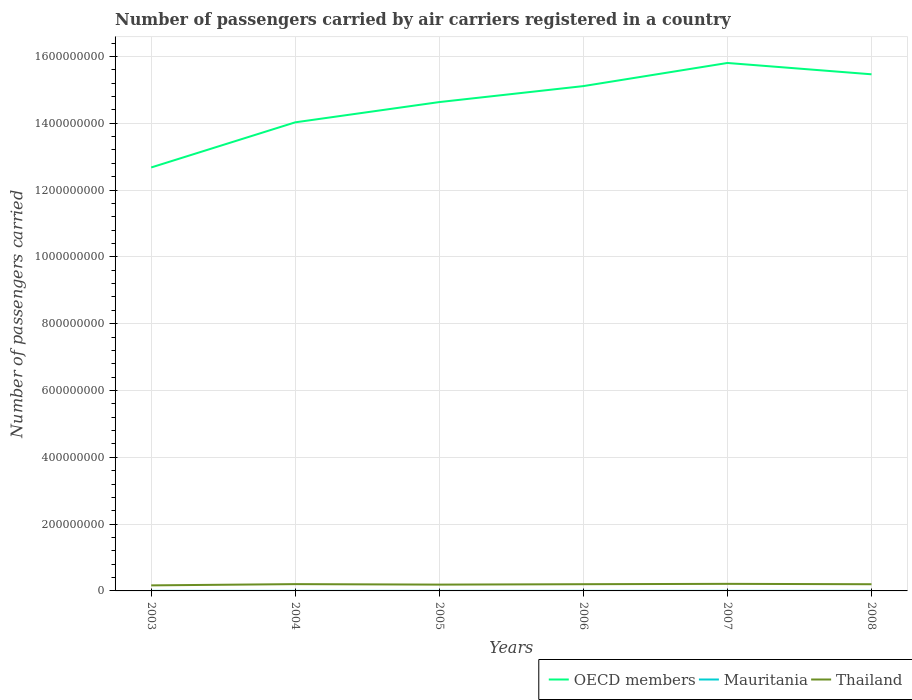Across all years, what is the maximum number of passengers carried by air carriers in OECD members?
Keep it short and to the point. 1.27e+09. In which year was the number of passengers carried by air carriers in OECD members maximum?
Give a very brief answer. 2003. What is the total number of passengers carried by air carriers in Thailand in the graph?
Your response must be concise. 1.20e+06. What is the difference between the highest and the second highest number of passengers carried by air carriers in Mauritania?
Your response must be concise. 3.85e+04. What is the difference between the highest and the lowest number of passengers carried by air carriers in Thailand?
Provide a succinct answer. 4. Are the values on the major ticks of Y-axis written in scientific E-notation?
Ensure brevity in your answer.  No. Does the graph contain any zero values?
Keep it short and to the point. No. Where does the legend appear in the graph?
Your answer should be compact. Bottom right. How many legend labels are there?
Your answer should be very brief. 3. How are the legend labels stacked?
Provide a short and direct response. Horizontal. What is the title of the graph?
Offer a terse response. Number of passengers carried by air carriers registered in a country. What is the label or title of the X-axis?
Offer a terse response. Years. What is the label or title of the Y-axis?
Make the answer very short. Number of passengers carried. What is the Number of passengers carried in OECD members in 2003?
Make the answer very short. 1.27e+09. What is the Number of passengers carried of Mauritania in 2003?
Offer a terse response. 1.16e+05. What is the Number of passengers carried in Thailand in 2003?
Provide a succinct answer. 1.66e+07. What is the Number of passengers carried in OECD members in 2004?
Keep it short and to the point. 1.40e+09. What is the Number of passengers carried in Mauritania in 2004?
Ensure brevity in your answer.  1.28e+05. What is the Number of passengers carried in Thailand in 2004?
Your response must be concise. 2.03e+07. What is the Number of passengers carried in OECD members in 2005?
Keep it short and to the point. 1.46e+09. What is the Number of passengers carried of Mauritania in 2005?
Offer a very short reply. 1.39e+05. What is the Number of passengers carried of Thailand in 2005?
Keep it short and to the point. 1.89e+07. What is the Number of passengers carried of OECD members in 2006?
Ensure brevity in your answer.  1.51e+09. What is the Number of passengers carried of Mauritania in 2006?
Ensure brevity in your answer.  1.49e+05. What is the Number of passengers carried in Thailand in 2006?
Keep it short and to the point. 2.01e+07. What is the Number of passengers carried of OECD members in 2007?
Your answer should be compact. 1.58e+09. What is the Number of passengers carried in Mauritania in 2007?
Your answer should be compact. 1.55e+05. What is the Number of passengers carried of Thailand in 2007?
Give a very brief answer. 2.12e+07. What is the Number of passengers carried of OECD members in 2008?
Make the answer very short. 1.55e+09. What is the Number of passengers carried of Mauritania in 2008?
Give a very brief answer. 1.54e+05. What is the Number of passengers carried of Thailand in 2008?
Your response must be concise. 2.00e+07. Across all years, what is the maximum Number of passengers carried in OECD members?
Give a very brief answer. 1.58e+09. Across all years, what is the maximum Number of passengers carried of Mauritania?
Keep it short and to the point. 1.55e+05. Across all years, what is the maximum Number of passengers carried in Thailand?
Keep it short and to the point. 2.12e+07. Across all years, what is the minimum Number of passengers carried in OECD members?
Keep it short and to the point. 1.27e+09. Across all years, what is the minimum Number of passengers carried in Mauritania?
Make the answer very short. 1.16e+05. Across all years, what is the minimum Number of passengers carried of Thailand?
Make the answer very short. 1.66e+07. What is the total Number of passengers carried of OECD members in the graph?
Your answer should be very brief. 8.77e+09. What is the total Number of passengers carried in Mauritania in the graph?
Keep it short and to the point. 8.41e+05. What is the total Number of passengers carried of Thailand in the graph?
Offer a terse response. 1.17e+08. What is the difference between the Number of passengers carried of OECD members in 2003 and that in 2004?
Make the answer very short. -1.35e+08. What is the difference between the Number of passengers carried of Mauritania in 2003 and that in 2004?
Offer a terse response. -1.22e+04. What is the difference between the Number of passengers carried of Thailand in 2003 and that in 2004?
Provide a succinct answer. -3.72e+06. What is the difference between the Number of passengers carried in OECD members in 2003 and that in 2005?
Keep it short and to the point. -1.96e+08. What is the difference between the Number of passengers carried in Mauritania in 2003 and that in 2005?
Make the answer very short. -2.25e+04. What is the difference between the Number of passengers carried of Thailand in 2003 and that in 2005?
Give a very brief answer. -2.28e+06. What is the difference between the Number of passengers carried in OECD members in 2003 and that in 2006?
Make the answer very short. -2.44e+08. What is the difference between the Number of passengers carried of Mauritania in 2003 and that in 2006?
Keep it short and to the point. -3.31e+04. What is the difference between the Number of passengers carried in Thailand in 2003 and that in 2006?
Give a very brief answer. -3.48e+06. What is the difference between the Number of passengers carried of OECD members in 2003 and that in 2007?
Give a very brief answer. -3.13e+08. What is the difference between the Number of passengers carried in Mauritania in 2003 and that in 2007?
Provide a short and direct response. -3.85e+04. What is the difference between the Number of passengers carried in Thailand in 2003 and that in 2007?
Offer a terse response. -4.57e+06. What is the difference between the Number of passengers carried in OECD members in 2003 and that in 2008?
Your response must be concise. -2.79e+08. What is the difference between the Number of passengers carried of Mauritania in 2003 and that in 2008?
Give a very brief answer. -3.78e+04. What is the difference between the Number of passengers carried of Thailand in 2003 and that in 2008?
Your answer should be compact. -3.37e+06. What is the difference between the Number of passengers carried in OECD members in 2004 and that in 2005?
Your answer should be compact. -6.06e+07. What is the difference between the Number of passengers carried in Mauritania in 2004 and that in 2005?
Make the answer very short. -1.03e+04. What is the difference between the Number of passengers carried in Thailand in 2004 and that in 2005?
Offer a very short reply. 1.44e+06. What is the difference between the Number of passengers carried in OECD members in 2004 and that in 2006?
Provide a succinct answer. -1.08e+08. What is the difference between the Number of passengers carried of Mauritania in 2004 and that in 2006?
Give a very brief answer. -2.09e+04. What is the difference between the Number of passengers carried in Thailand in 2004 and that in 2006?
Provide a succinct answer. 2.40e+05. What is the difference between the Number of passengers carried in OECD members in 2004 and that in 2007?
Offer a very short reply. -1.78e+08. What is the difference between the Number of passengers carried in Mauritania in 2004 and that in 2007?
Offer a very short reply. -2.63e+04. What is the difference between the Number of passengers carried of Thailand in 2004 and that in 2007?
Your answer should be compact. -8.49e+05. What is the difference between the Number of passengers carried in OECD members in 2004 and that in 2008?
Your answer should be compact. -1.44e+08. What is the difference between the Number of passengers carried in Mauritania in 2004 and that in 2008?
Your answer should be very brief. -2.56e+04. What is the difference between the Number of passengers carried of Thailand in 2004 and that in 2008?
Make the answer very short. 3.49e+05. What is the difference between the Number of passengers carried in OECD members in 2005 and that in 2006?
Give a very brief answer. -4.78e+07. What is the difference between the Number of passengers carried of Mauritania in 2005 and that in 2006?
Keep it short and to the point. -1.06e+04. What is the difference between the Number of passengers carried in Thailand in 2005 and that in 2006?
Provide a short and direct response. -1.20e+06. What is the difference between the Number of passengers carried in OECD members in 2005 and that in 2007?
Ensure brevity in your answer.  -1.17e+08. What is the difference between the Number of passengers carried in Mauritania in 2005 and that in 2007?
Offer a very short reply. -1.61e+04. What is the difference between the Number of passengers carried of Thailand in 2005 and that in 2007?
Your answer should be very brief. -2.29e+06. What is the difference between the Number of passengers carried of OECD members in 2005 and that in 2008?
Your response must be concise. -8.31e+07. What is the difference between the Number of passengers carried in Mauritania in 2005 and that in 2008?
Ensure brevity in your answer.  -1.53e+04. What is the difference between the Number of passengers carried in Thailand in 2005 and that in 2008?
Provide a short and direct response. -1.09e+06. What is the difference between the Number of passengers carried in OECD members in 2006 and that in 2007?
Provide a short and direct response. -6.92e+07. What is the difference between the Number of passengers carried in Mauritania in 2006 and that in 2007?
Make the answer very short. -5474. What is the difference between the Number of passengers carried of Thailand in 2006 and that in 2007?
Make the answer very short. -1.09e+06. What is the difference between the Number of passengers carried of OECD members in 2006 and that in 2008?
Give a very brief answer. -3.53e+07. What is the difference between the Number of passengers carried of Mauritania in 2006 and that in 2008?
Your answer should be compact. -4707. What is the difference between the Number of passengers carried in Thailand in 2006 and that in 2008?
Your response must be concise. 1.09e+05. What is the difference between the Number of passengers carried of OECD members in 2007 and that in 2008?
Your answer should be very brief. 3.39e+07. What is the difference between the Number of passengers carried of Mauritania in 2007 and that in 2008?
Give a very brief answer. 767. What is the difference between the Number of passengers carried in Thailand in 2007 and that in 2008?
Your answer should be compact. 1.20e+06. What is the difference between the Number of passengers carried of OECD members in 2003 and the Number of passengers carried of Mauritania in 2004?
Offer a very short reply. 1.27e+09. What is the difference between the Number of passengers carried of OECD members in 2003 and the Number of passengers carried of Thailand in 2004?
Your answer should be very brief. 1.25e+09. What is the difference between the Number of passengers carried in Mauritania in 2003 and the Number of passengers carried in Thailand in 2004?
Make the answer very short. -2.02e+07. What is the difference between the Number of passengers carried in OECD members in 2003 and the Number of passengers carried in Mauritania in 2005?
Make the answer very short. 1.27e+09. What is the difference between the Number of passengers carried in OECD members in 2003 and the Number of passengers carried in Thailand in 2005?
Keep it short and to the point. 1.25e+09. What is the difference between the Number of passengers carried in Mauritania in 2003 and the Number of passengers carried in Thailand in 2005?
Your answer should be very brief. -1.88e+07. What is the difference between the Number of passengers carried in OECD members in 2003 and the Number of passengers carried in Mauritania in 2006?
Make the answer very short. 1.27e+09. What is the difference between the Number of passengers carried in OECD members in 2003 and the Number of passengers carried in Thailand in 2006?
Provide a short and direct response. 1.25e+09. What is the difference between the Number of passengers carried in Mauritania in 2003 and the Number of passengers carried in Thailand in 2006?
Offer a very short reply. -2.00e+07. What is the difference between the Number of passengers carried in OECD members in 2003 and the Number of passengers carried in Mauritania in 2007?
Offer a terse response. 1.27e+09. What is the difference between the Number of passengers carried of OECD members in 2003 and the Number of passengers carried of Thailand in 2007?
Your response must be concise. 1.25e+09. What is the difference between the Number of passengers carried in Mauritania in 2003 and the Number of passengers carried in Thailand in 2007?
Your answer should be very brief. -2.11e+07. What is the difference between the Number of passengers carried of OECD members in 2003 and the Number of passengers carried of Mauritania in 2008?
Give a very brief answer. 1.27e+09. What is the difference between the Number of passengers carried in OECD members in 2003 and the Number of passengers carried in Thailand in 2008?
Offer a terse response. 1.25e+09. What is the difference between the Number of passengers carried of Mauritania in 2003 and the Number of passengers carried of Thailand in 2008?
Provide a succinct answer. -1.99e+07. What is the difference between the Number of passengers carried of OECD members in 2004 and the Number of passengers carried of Mauritania in 2005?
Provide a succinct answer. 1.40e+09. What is the difference between the Number of passengers carried of OECD members in 2004 and the Number of passengers carried of Thailand in 2005?
Provide a short and direct response. 1.38e+09. What is the difference between the Number of passengers carried in Mauritania in 2004 and the Number of passengers carried in Thailand in 2005?
Offer a terse response. -1.88e+07. What is the difference between the Number of passengers carried of OECD members in 2004 and the Number of passengers carried of Mauritania in 2006?
Offer a terse response. 1.40e+09. What is the difference between the Number of passengers carried in OECD members in 2004 and the Number of passengers carried in Thailand in 2006?
Provide a short and direct response. 1.38e+09. What is the difference between the Number of passengers carried of Mauritania in 2004 and the Number of passengers carried of Thailand in 2006?
Your answer should be very brief. -2.00e+07. What is the difference between the Number of passengers carried of OECD members in 2004 and the Number of passengers carried of Mauritania in 2007?
Your answer should be compact. 1.40e+09. What is the difference between the Number of passengers carried in OECD members in 2004 and the Number of passengers carried in Thailand in 2007?
Keep it short and to the point. 1.38e+09. What is the difference between the Number of passengers carried in Mauritania in 2004 and the Number of passengers carried in Thailand in 2007?
Your answer should be very brief. -2.11e+07. What is the difference between the Number of passengers carried of OECD members in 2004 and the Number of passengers carried of Mauritania in 2008?
Your answer should be very brief. 1.40e+09. What is the difference between the Number of passengers carried in OECD members in 2004 and the Number of passengers carried in Thailand in 2008?
Provide a succinct answer. 1.38e+09. What is the difference between the Number of passengers carried in Mauritania in 2004 and the Number of passengers carried in Thailand in 2008?
Your response must be concise. -1.99e+07. What is the difference between the Number of passengers carried in OECD members in 2005 and the Number of passengers carried in Mauritania in 2006?
Give a very brief answer. 1.46e+09. What is the difference between the Number of passengers carried in OECD members in 2005 and the Number of passengers carried in Thailand in 2006?
Your response must be concise. 1.44e+09. What is the difference between the Number of passengers carried of Mauritania in 2005 and the Number of passengers carried of Thailand in 2006?
Your response must be concise. -2.00e+07. What is the difference between the Number of passengers carried of OECD members in 2005 and the Number of passengers carried of Mauritania in 2007?
Your answer should be compact. 1.46e+09. What is the difference between the Number of passengers carried in OECD members in 2005 and the Number of passengers carried in Thailand in 2007?
Your answer should be very brief. 1.44e+09. What is the difference between the Number of passengers carried in Mauritania in 2005 and the Number of passengers carried in Thailand in 2007?
Your response must be concise. -2.11e+07. What is the difference between the Number of passengers carried of OECD members in 2005 and the Number of passengers carried of Mauritania in 2008?
Give a very brief answer. 1.46e+09. What is the difference between the Number of passengers carried in OECD members in 2005 and the Number of passengers carried in Thailand in 2008?
Your response must be concise. 1.44e+09. What is the difference between the Number of passengers carried in Mauritania in 2005 and the Number of passengers carried in Thailand in 2008?
Provide a short and direct response. -1.99e+07. What is the difference between the Number of passengers carried of OECD members in 2006 and the Number of passengers carried of Mauritania in 2007?
Your answer should be very brief. 1.51e+09. What is the difference between the Number of passengers carried of OECD members in 2006 and the Number of passengers carried of Thailand in 2007?
Provide a succinct answer. 1.49e+09. What is the difference between the Number of passengers carried of Mauritania in 2006 and the Number of passengers carried of Thailand in 2007?
Make the answer very short. -2.10e+07. What is the difference between the Number of passengers carried in OECD members in 2006 and the Number of passengers carried in Mauritania in 2008?
Make the answer very short. 1.51e+09. What is the difference between the Number of passengers carried of OECD members in 2006 and the Number of passengers carried of Thailand in 2008?
Ensure brevity in your answer.  1.49e+09. What is the difference between the Number of passengers carried in Mauritania in 2006 and the Number of passengers carried in Thailand in 2008?
Provide a succinct answer. -1.98e+07. What is the difference between the Number of passengers carried in OECD members in 2007 and the Number of passengers carried in Mauritania in 2008?
Give a very brief answer. 1.58e+09. What is the difference between the Number of passengers carried in OECD members in 2007 and the Number of passengers carried in Thailand in 2008?
Your answer should be very brief. 1.56e+09. What is the difference between the Number of passengers carried of Mauritania in 2007 and the Number of passengers carried of Thailand in 2008?
Ensure brevity in your answer.  -1.98e+07. What is the average Number of passengers carried of OECD members per year?
Ensure brevity in your answer.  1.46e+09. What is the average Number of passengers carried of Mauritania per year?
Your answer should be compact. 1.40e+05. What is the average Number of passengers carried of Thailand per year?
Keep it short and to the point. 1.95e+07. In the year 2003, what is the difference between the Number of passengers carried in OECD members and Number of passengers carried in Mauritania?
Make the answer very short. 1.27e+09. In the year 2003, what is the difference between the Number of passengers carried of OECD members and Number of passengers carried of Thailand?
Make the answer very short. 1.25e+09. In the year 2003, what is the difference between the Number of passengers carried in Mauritania and Number of passengers carried in Thailand?
Your answer should be compact. -1.65e+07. In the year 2004, what is the difference between the Number of passengers carried of OECD members and Number of passengers carried of Mauritania?
Your answer should be compact. 1.40e+09. In the year 2004, what is the difference between the Number of passengers carried of OECD members and Number of passengers carried of Thailand?
Your answer should be very brief. 1.38e+09. In the year 2004, what is the difference between the Number of passengers carried of Mauritania and Number of passengers carried of Thailand?
Keep it short and to the point. -2.02e+07. In the year 2005, what is the difference between the Number of passengers carried in OECD members and Number of passengers carried in Mauritania?
Provide a short and direct response. 1.46e+09. In the year 2005, what is the difference between the Number of passengers carried of OECD members and Number of passengers carried of Thailand?
Give a very brief answer. 1.44e+09. In the year 2005, what is the difference between the Number of passengers carried in Mauritania and Number of passengers carried in Thailand?
Make the answer very short. -1.88e+07. In the year 2006, what is the difference between the Number of passengers carried of OECD members and Number of passengers carried of Mauritania?
Your answer should be compact. 1.51e+09. In the year 2006, what is the difference between the Number of passengers carried in OECD members and Number of passengers carried in Thailand?
Ensure brevity in your answer.  1.49e+09. In the year 2006, what is the difference between the Number of passengers carried of Mauritania and Number of passengers carried of Thailand?
Offer a very short reply. -2.00e+07. In the year 2007, what is the difference between the Number of passengers carried of OECD members and Number of passengers carried of Mauritania?
Ensure brevity in your answer.  1.58e+09. In the year 2007, what is the difference between the Number of passengers carried of OECD members and Number of passengers carried of Thailand?
Provide a short and direct response. 1.56e+09. In the year 2007, what is the difference between the Number of passengers carried in Mauritania and Number of passengers carried in Thailand?
Offer a very short reply. -2.10e+07. In the year 2008, what is the difference between the Number of passengers carried of OECD members and Number of passengers carried of Mauritania?
Offer a very short reply. 1.55e+09. In the year 2008, what is the difference between the Number of passengers carried in OECD members and Number of passengers carried in Thailand?
Your response must be concise. 1.53e+09. In the year 2008, what is the difference between the Number of passengers carried in Mauritania and Number of passengers carried in Thailand?
Make the answer very short. -1.98e+07. What is the ratio of the Number of passengers carried in OECD members in 2003 to that in 2004?
Make the answer very short. 0.9. What is the ratio of the Number of passengers carried of Mauritania in 2003 to that in 2004?
Offer a terse response. 0.91. What is the ratio of the Number of passengers carried of Thailand in 2003 to that in 2004?
Provide a short and direct response. 0.82. What is the ratio of the Number of passengers carried in OECD members in 2003 to that in 2005?
Keep it short and to the point. 0.87. What is the ratio of the Number of passengers carried in Mauritania in 2003 to that in 2005?
Provide a short and direct response. 0.84. What is the ratio of the Number of passengers carried in Thailand in 2003 to that in 2005?
Provide a succinct answer. 0.88. What is the ratio of the Number of passengers carried of OECD members in 2003 to that in 2006?
Your answer should be compact. 0.84. What is the ratio of the Number of passengers carried in Mauritania in 2003 to that in 2006?
Keep it short and to the point. 0.78. What is the ratio of the Number of passengers carried of Thailand in 2003 to that in 2006?
Your response must be concise. 0.83. What is the ratio of the Number of passengers carried of OECD members in 2003 to that in 2007?
Your response must be concise. 0.8. What is the ratio of the Number of passengers carried in Mauritania in 2003 to that in 2007?
Keep it short and to the point. 0.75. What is the ratio of the Number of passengers carried of Thailand in 2003 to that in 2007?
Your answer should be compact. 0.78. What is the ratio of the Number of passengers carried in OECD members in 2003 to that in 2008?
Your answer should be very brief. 0.82. What is the ratio of the Number of passengers carried of Mauritania in 2003 to that in 2008?
Keep it short and to the point. 0.75. What is the ratio of the Number of passengers carried of Thailand in 2003 to that in 2008?
Offer a very short reply. 0.83. What is the ratio of the Number of passengers carried in OECD members in 2004 to that in 2005?
Your answer should be compact. 0.96. What is the ratio of the Number of passengers carried in Mauritania in 2004 to that in 2005?
Provide a succinct answer. 0.93. What is the ratio of the Number of passengers carried of Thailand in 2004 to that in 2005?
Keep it short and to the point. 1.08. What is the ratio of the Number of passengers carried of OECD members in 2004 to that in 2006?
Keep it short and to the point. 0.93. What is the ratio of the Number of passengers carried of Mauritania in 2004 to that in 2006?
Offer a terse response. 0.86. What is the ratio of the Number of passengers carried of Thailand in 2004 to that in 2006?
Keep it short and to the point. 1.01. What is the ratio of the Number of passengers carried of OECD members in 2004 to that in 2007?
Give a very brief answer. 0.89. What is the ratio of the Number of passengers carried of Mauritania in 2004 to that in 2007?
Give a very brief answer. 0.83. What is the ratio of the Number of passengers carried of Thailand in 2004 to that in 2007?
Your answer should be compact. 0.96. What is the ratio of the Number of passengers carried in OECD members in 2004 to that in 2008?
Your answer should be very brief. 0.91. What is the ratio of the Number of passengers carried in Mauritania in 2004 to that in 2008?
Make the answer very short. 0.83. What is the ratio of the Number of passengers carried of Thailand in 2004 to that in 2008?
Offer a terse response. 1.02. What is the ratio of the Number of passengers carried in OECD members in 2005 to that in 2006?
Keep it short and to the point. 0.97. What is the ratio of the Number of passengers carried of Mauritania in 2005 to that in 2006?
Provide a succinct answer. 0.93. What is the ratio of the Number of passengers carried of Thailand in 2005 to that in 2006?
Provide a succinct answer. 0.94. What is the ratio of the Number of passengers carried in OECD members in 2005 to that in 2007?
Your answer should be compact. 0.93. What is the ratio of the Number of passengers carried in Mauritania in 2005 to that in 2007?
Your response must be concise. 0.9. What is the ratio of the Number of passengers carried of Thailand in 2005 to that in 2007?
Your answer should be very brief. 0.89. What is the ratio of the Number of passengers carried of OECD members in 2005 to that in 2008?
Keep it short and to the point. 0.95. What is the ratio of the Number of passengers carried in Mauritania in 2005 to that in 2008?
Give a very brief answer. 0.9. What is the ratio of the Number of passengers carried of Thailand in 2005 to that in 2008?
Provide a short and direct response. 0.95. What is the ratio of the Number of passengers carried in OECD members in 2006 to that in 2007?
Offer a terse response. 0.96. What is the ratio of the Number of passengers carried of Mauritania in 2006 to that in 2007?
Offer a very short reply. 0.96. What is the ratio of the Number of passengers carried of Thailand in 2006 to that in 2007?
Give a very brief answer. 0.95. What is the ratio of the Number of passengers carried in OECD members in 2006 to that in 2008?
Give a very brief answer. 0.98. What is the ratio of the Number of passengers carried in Mauritania in 2006 to that in 2008?
Give a very brief answer. 0.97. What is the ratio of the Number of passengers carried of Thailand in 2006 to that in 2008?
Provide a short and direct response. 1.01. What is the ratio of the Number of passengers carried in OECD members in 2007 to that in 2008?
Your response must be concise. 1.02. What is the ratio of the Number of passengers carried of Thailand in 2007 to that in 2008?
Ensure brevity in your answer.  1.06. What is the difference between the highest and the second highest Number of passengers carried of OECD members?
Your response must be concise. 3.39e+07. What is the difference between the highest and the second highest Number of passengers carried in Mauritania?
Keep it short and to the point. 767. What is the difference between the highest and the second highest Number of passengers carried of Thailand?
Your response must be concise. 8.49e+05. What is the difference between the highest and the lowest Number of passengers carried in OECD members?
Your answer should be compact. 3.13e+08. What is the difference between the highest and the lowest Number of passengers carried of Mauritania?
Offer a very short reply. 3.85e+04. What is the difference between the highest and the lowest Number of passengers carried of Thailand?
Offer a terse response. 4.57e+06. 